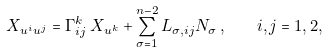<formula> <loc_0><loc_0><loc_500><loc_500>X _ { u ^ { i } u ^ { j } } = \Gamma _ { i j } ^ { k } \, X _ { u ^ { k } } + \sum _ { \sigma = 1 } ^ { n - 2 } L _ { \sigma , i j } N _ { \sigma } \, , \quad i , j = 1 , 2 ,</formula> 